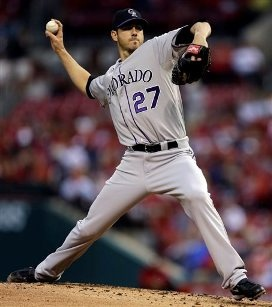Describe the objects in this image and their specific colors. I can see people in black, darkgray, lightgray, and gray tones, baseball glove in black, gray, brown, and maroon tones, and sports ball in black, tan, and beige tones in this image. 